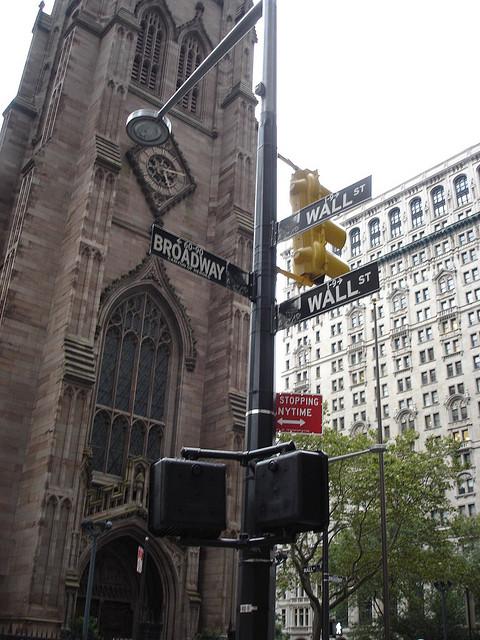Is this an old church?
Answer briefly. Yes. What state is this intersection in?
Concise answer only. New york. How many streets are advertised?
Short answer required. 2. 